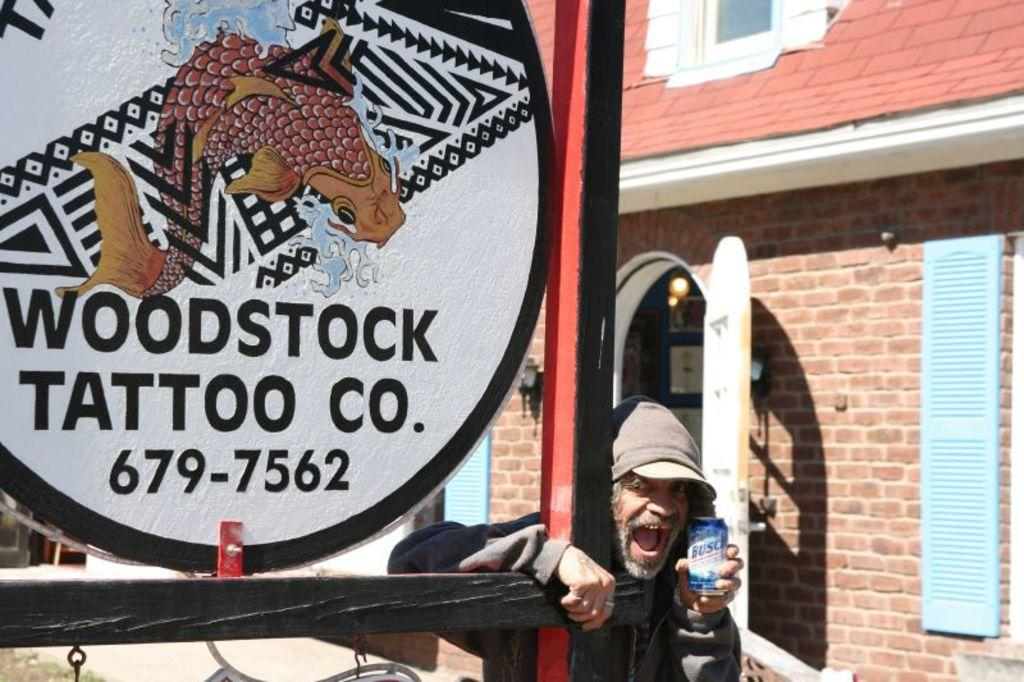What type of structure is visible in the image? There is a building in the image. What object is present near the building? There is a board in the image. Who is standing in front of the board? A person is standing in front of the board. What is the person holding? The person is holding a tin. Reasoning: Let's think step by step by step in order to produce the conversation. We start by mentioning the main structure in the image, which is the building. Then, we describe the object near the building, which is the board. Next, we focus on the person in the image and their actions, noting that they are standing in front of the board and holding a tin. Each question is designed to elicit a specific detail about the image that is known from the provided facts. Absurd Question/Answer: What type of powder can be seen falling from the person's hands in the image? There is no powder visible in the image, nor is there any indication that the person is holding or releasing any powder. What type of flesh can be seen on the person's hands in the image? There is no flesh visible on the person's hands in the image, nor is there any indication that the person's hands are exposed or displaying any flesh. --- Facts: 1. There is a person sitting on a chair in the image. 2. The person is holding a book. 3. The book has a red cover. 4. There is a table next to the chair. 5. A lamp is on the table. Absurd Topics: fish, sand, bicycle Conversation: What is the person in the image doing? The person is sitting on a chair in the image. What is the person holding? The person is holding a book. What color is the book's cover? The book has a red cover. What object is on the table next to the chair? A lamp is on the table. Reasoning: Let's think step by step in order to produce the conversation. We start by identifying the main subject in the image, which is the person sitting on a chair. Then, we describe what the person is holding, which is a book with a red cover. Next, we mention the 